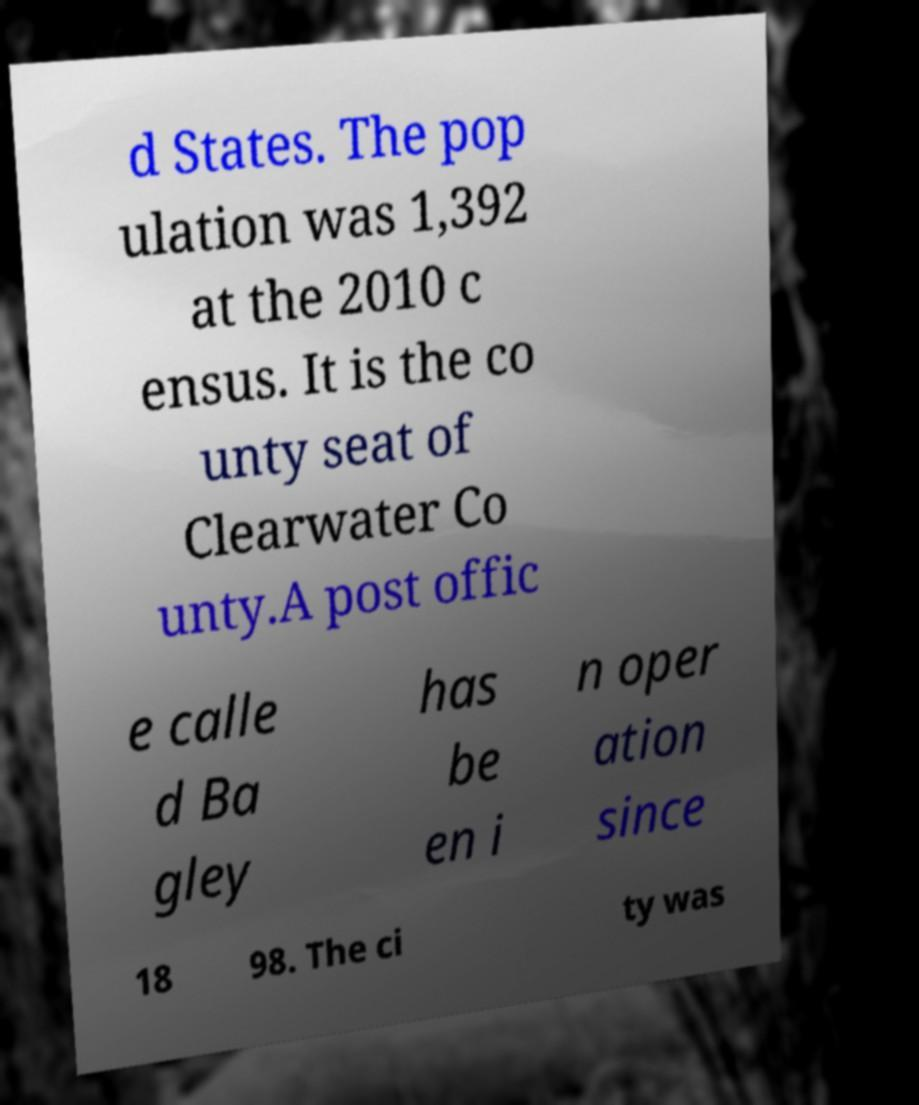Could you assist in decoding the text presented in this image and type it out clearly? d States. The pop ulation was 1,392 at the 2010 c ensus. It is the co unty seat of Clearwater Co unty.A post offic e calle d Ba gley has be en i n oper ation since 18 98. The ci ty was 